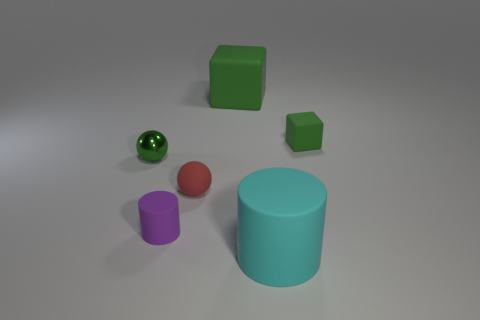The other rubber cube that is the same color as the big matte cube is what size?
Provide a short and direct response. Small. What shape is the rubber object that is the same color as the large rubber cube?
Your answer should be very brief. Cube. Are there any green spheres that have the same size as the red ball?
Offer a terse response. Yes. There is a ball that is in front of the sphere that is left of the small rubber cylinder; what is its size?
Offer a very short reply. Small. Is the number of large rubber cylinders left of the tiny purple matte thing less than the number of rubber balls?
Offer a terse response. Yes. Do the large cube and the shiny ball have the same color?
Ensure brevity in your answer.  Yes. The shiny object is what size?
Provide a short and direct response. Small. What number of small balls are the same color as the large block?
Provide a succinct answer. 1. There is a small green object on the left side of the sphere that is right of the purple cylinder; are there any shiny things that are to the left of it?
Make the answer very short. No. What shape is the matte object that is the same size as the cyan rubber cylinder?
Ensure brevity in your answer.  Cube. 